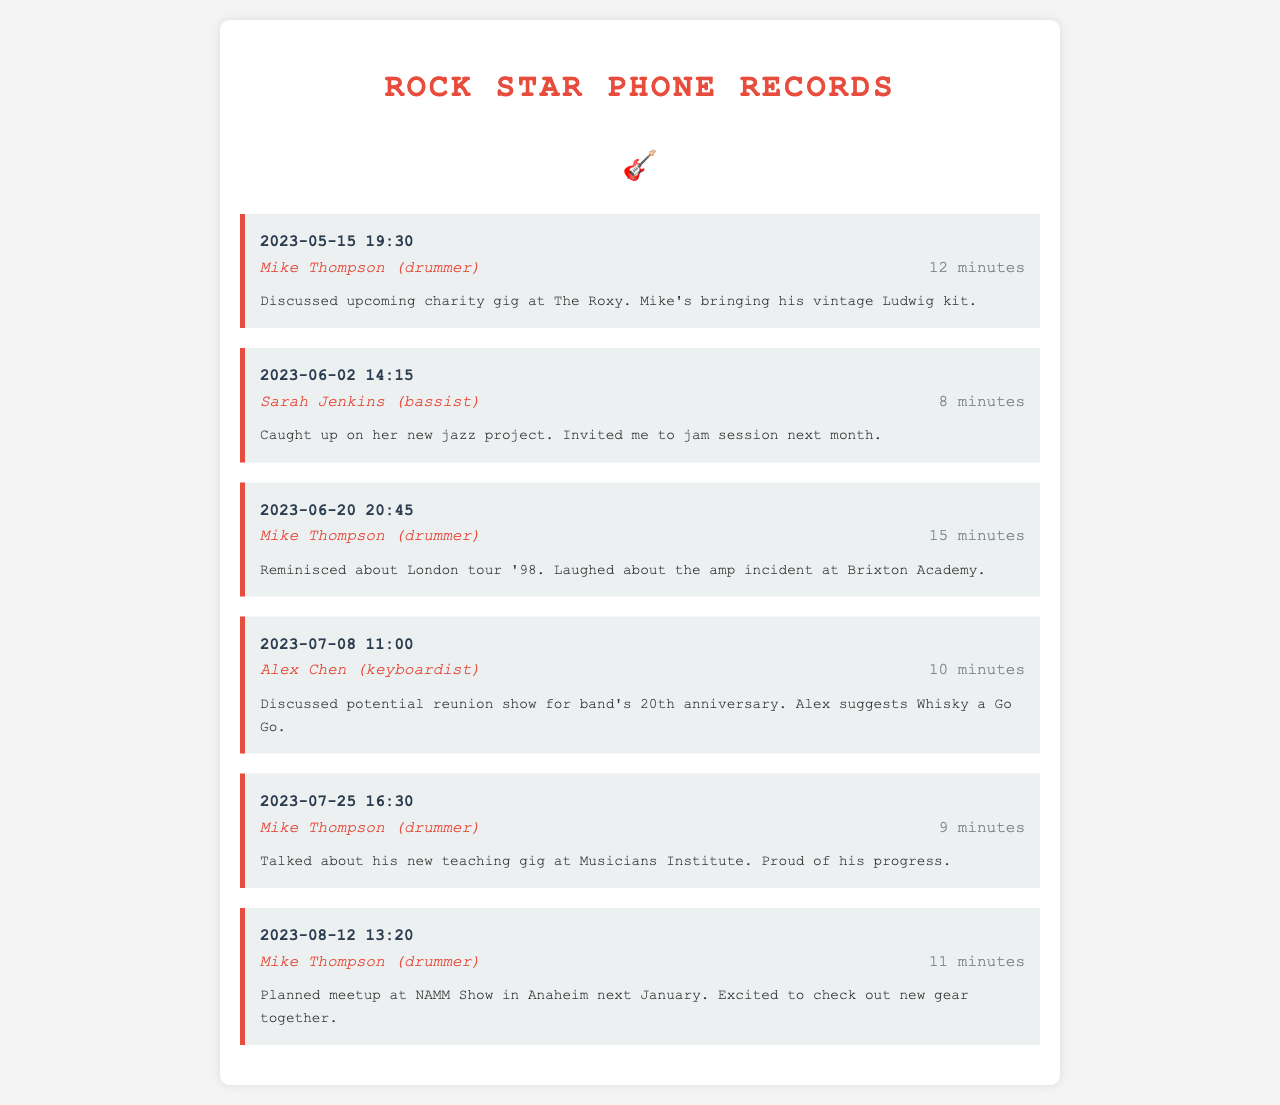what date did Mike Thompson discuss the charity gig? The charity gig discussion with Mike Thompson occurred on May 15, 2023.
Answer: May 15, 2023 how long was the call with Sarah Jenkins? The call duration with Sarah Jenkins was mentioned as 8 minutes.
Answer: 8 minutes what was discussed during the call on June 20? During the June 20 call with Mike Thompson, they reminisced about the London tour '98 and laughed about an incident.
Answer: London tour '98 who suggested the venue for the band's 20th anniversary reunion show? Alex Chen suggested Whisky a Go Go for the reunion show during the call on July 8.
Answer: Alex Chen how many minutes did Mike Thompson talk about his teaching gig? The duration of the conversation about Mike Thompson's teaching gig was 9 minutes.
Answer: 9 minutes when is the planned meetup at the NAMM Show? The planned meetup at the NAMM Show is set for January.
Answer: January what instrument does Mike Thompson play? Mike Thompson is identified as the drummer in the phone records.
Answer: drummer 